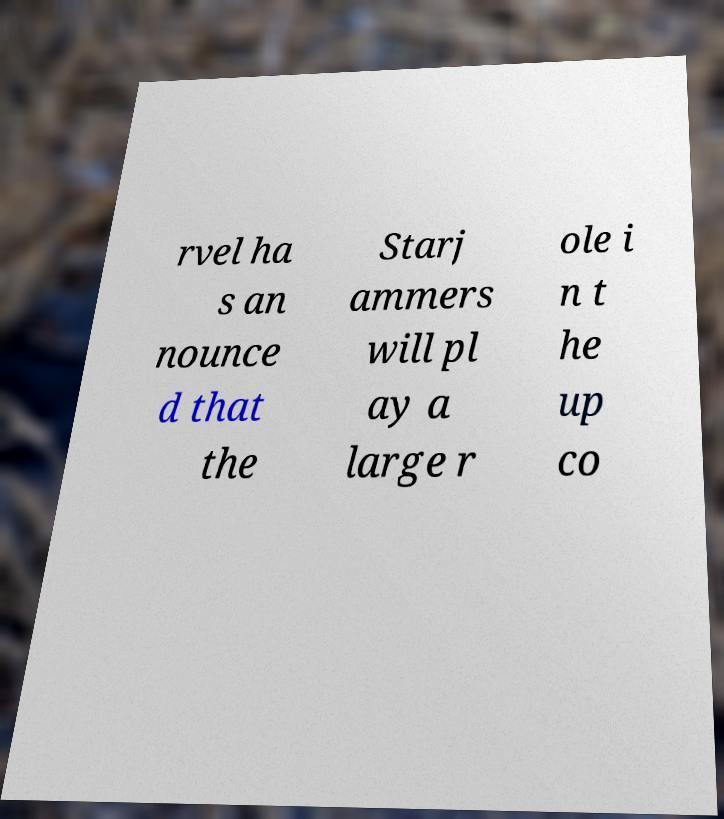Please identify and transcribe the text found in this image. rvel ha s an nounce d that the Starj ammers will pl ay a large r ole i n t he up co 